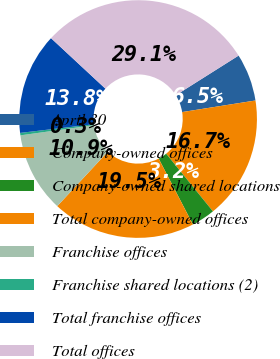<chart> <loc_0><loc_0><loc_500><loc_500><pie_chart><fcel>April 30<fcel>Company-owned offices<fcel>Company-owned shared locations<fcel>Total company-owned offices<fcel>Franchise offices<fcel>Franchise shared locations (2)<fcel>Total franchise offices<fcel>Total offices<nl><fcel>6.47%<fcel>16.66%<fcel>3.21%<fcel>19.54%<fcel>10.9%<fcel>0.33%<fcel>13.78%<fcel>29.13%<nl></chart> 